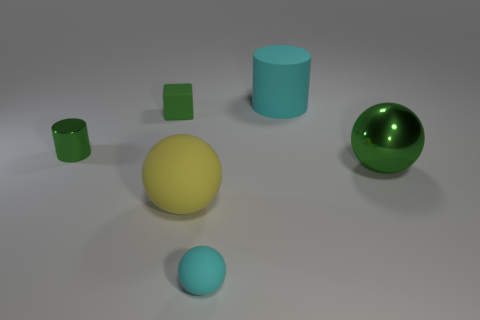Add 3 big yellow objects. How many objects exist? 9 Subtract all cylinders. How many objects are left? 4 Subtract 0 yellow cylinders. How many objects are left? 6 Subtract all tiny green metal cylinders. Subtract all cyan cylinders. How many objects are left? 4 Add 5 small matte cubes. How many small matte cubes are left? 6 Add 3 gray metallic balls. How many gray metallic balls exist? 3 